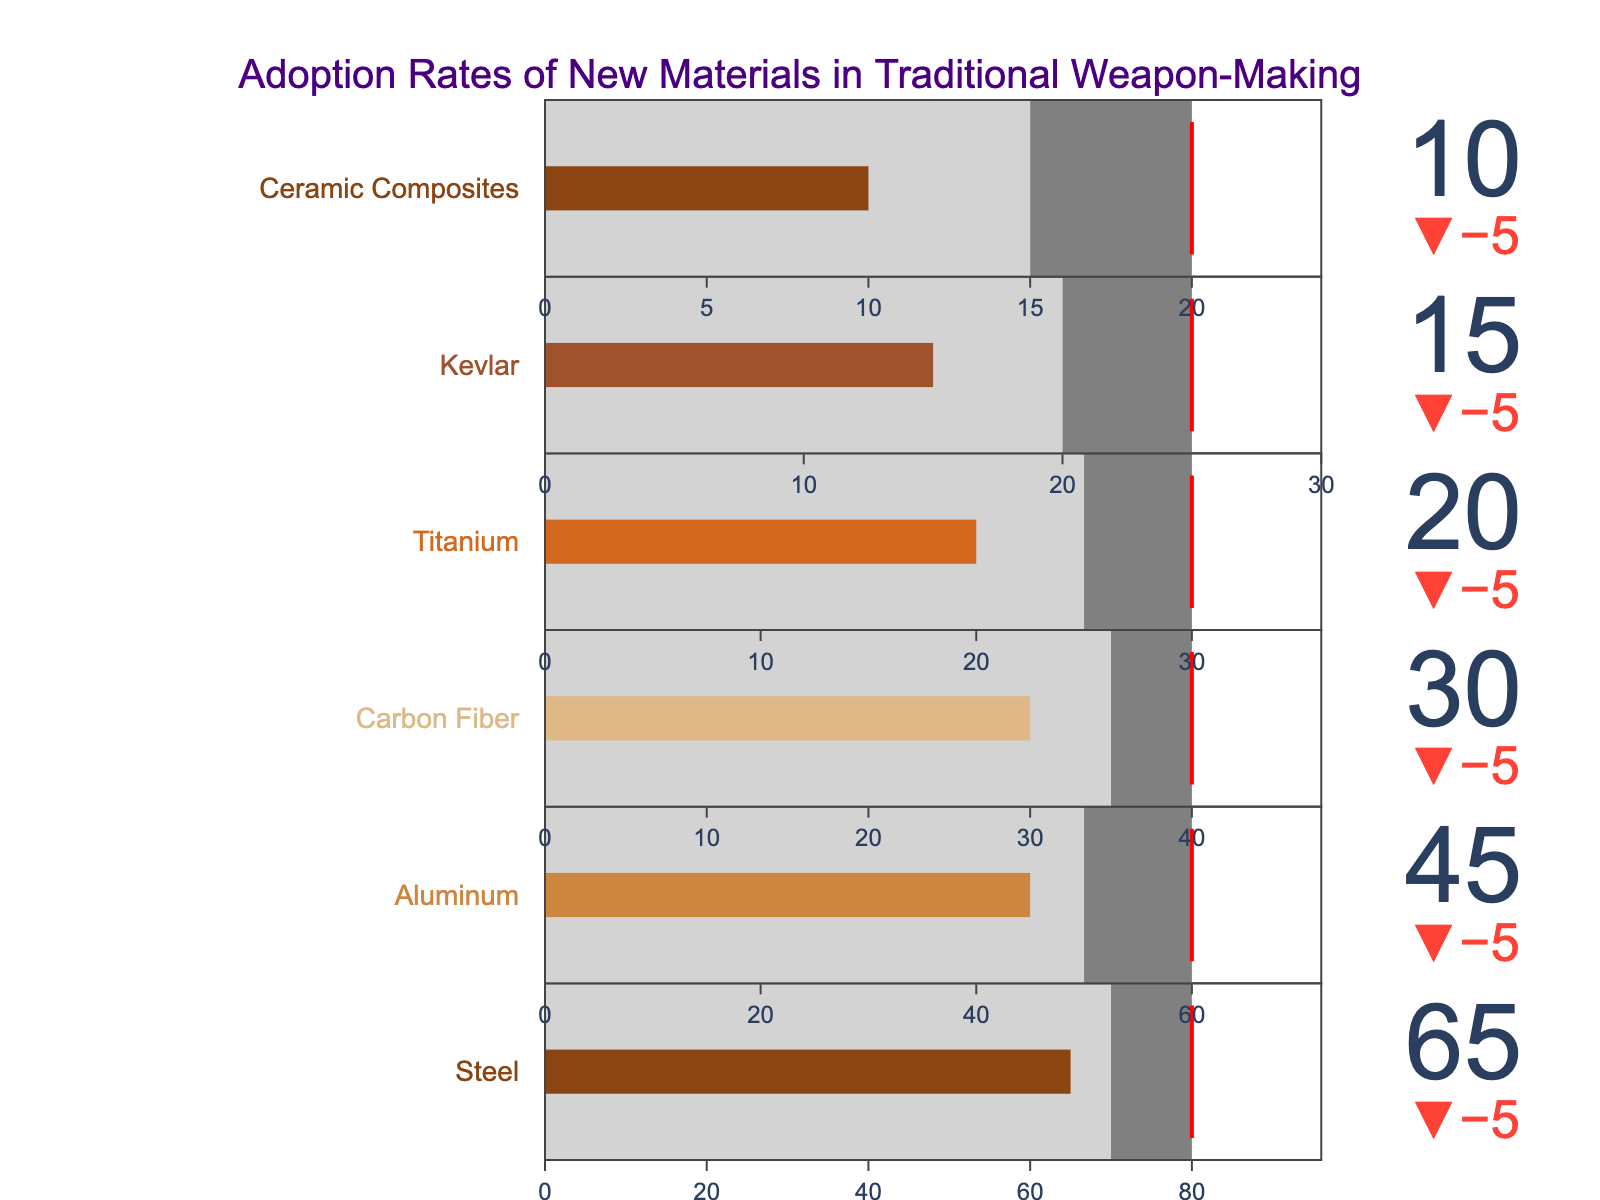Which material has the highest actual adoption rate? To determine which material has the highest actual adoption rate, look at the actual values for all materials and identify the largest. Steel has the highest actual adoption rate at 65.
Answer: Steel How far is the actual adoption rate of Kevlar from its target? The target adoption rate for Kevlar is shown as 25, while its actual rate is 15. The difference is 25 - 15 = 10.
Answer: 10 Which materials have an actual adoption rate higher than their comparative values? To find out which materials have higher actual adoption rates than their comparative values, compare these two metrics for each material. Steel (65 > 70) does not, Aluminum (45 > 50) does not, Carbon Fiber (30 > 35) does not, Titanium (20 > 25) does not, Kevlar (15 > 20) does not, and Ceramic Composites (10 > 15) does not. Thus, none of the materials have an actual adoption rate higher than their comparative values.
Answer: None What is the difference between the highest and the lowest target values? The highest target value is for Steel at 80, and the lowest is for Ceramic Composites at 20. The difference is 80 - 20 = 60.
Answer: 60 Which material has the smallest difference between its actual and comparative adoption rates? Calculate the differences between actual and comparative values for each material: Steel: 70-65=5, Aluminum: 50-45=5, Carbon Fiber: 35-30=5, Titanium: 25-20=5, Kevlar: 20-15=5, Ceramic Composites: 15-10=5. All materials have the same difference of 5 between actual and comparative values.
Answer: All materials What is the sum of the actual adoption rates for all materials? The actual adoption rates are summed as follows: 65 + 45 + 30 + 20 + 15 + 10 = 185.
Answer: 185 Which material has the greatest gap between its comparative and target values? Check the differences between comparative and target values for each material: Steel: 80-70=10, Aluminum: 60-50=10, Carbon Fiber: 40-35=5, Titanium: 30-25=5, Kevlar: 25-20=5, Ceramic Composites: 20-15=5. Both Steel and Aluminum have the greatest gap of 10.
Answer: Steel and Aluminum Which material falls short of its target by the biggest margin? Calculate the shortfall for each material: Steel: 80-65=15, Aluminum: 60-45=15, Carbon Fiber: 40-30=10, Titanium: 30-20=10, Kevlar: 25-15=10, Ceramic Composites: 20-10=10. Both Steel and Aluminum fall short of their targets by 15. Thus, these materials fall short by the biggest margin of 15.
Answer: Steel and Aluminum 